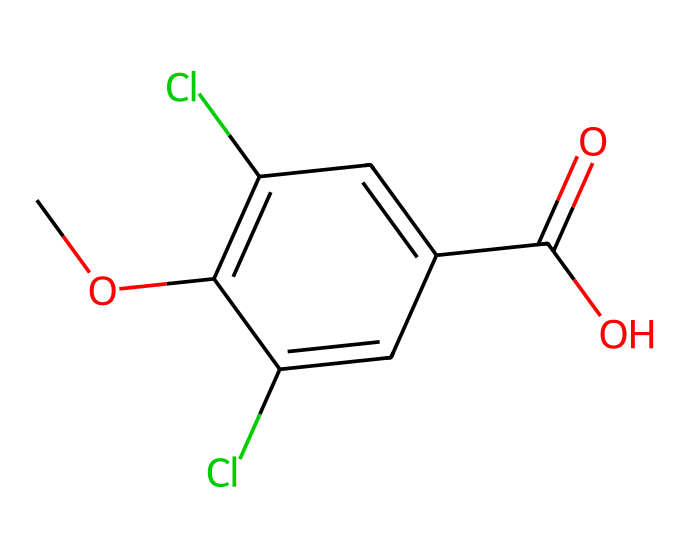How many chlorine (Cl) atoms are present in the structure? The SMILES representation shows two occurrences of "Cl," indicating the presence of two chlorine atoms.
Answer: 2 What functional group is represented in this chemical? The presence of "C(=O)O" in the SMILES indicates that there is a carboxylic acid functional group in the chemical structure.
Answer: carboxylic acid What is the total number of carbon (C) atoms in the structure? By examining the SMILES representation, we can count six carbon atoms, as each 'c' represents a carbon atom in the aromatic ring and there are additional carbon atoms in the carboxylic acid.
Answer: 6 Which part of the molecule contributes to its herbicidal activity? The chlorinated aromatic ring structure is known for contributing to the herbicidal activity of dicamba, allowing for effective weed control.
Answer: chlorinated aromatic ring How can the presence of chlorine atoms affect the chemical's environmental behavior? Chlorine atoms can increase the persistence of dicamba in the environment, making it more resistant to microbial degradation, which is linked to drift damage in lawsuits.
Answer: persistence What is the significance of the methoxy group (OCH3) in the chemical's properties? The methoxy group can enhance the lipophilicity of the molecule, influencing its absorption and transportation within plants, impacting its efficacy as a herbicide.
Answer: lipophilicity 